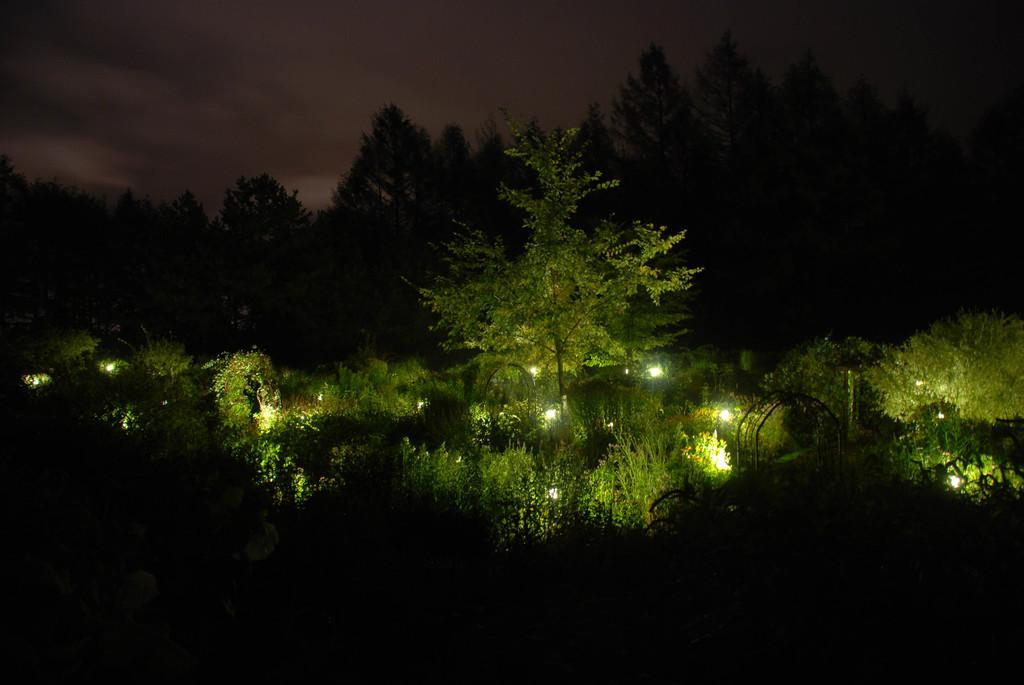What type of vegetation can be seen in the image? There are trees in the image. What objects are providing illumination in the image? There are lights in the image. What is visible at the top of the image? The sky is visible at the top of the image. What type of weather can be seen on the tongue of the person in the image? There is no person present in the image, and therefore no tongue or weather can be observed. 